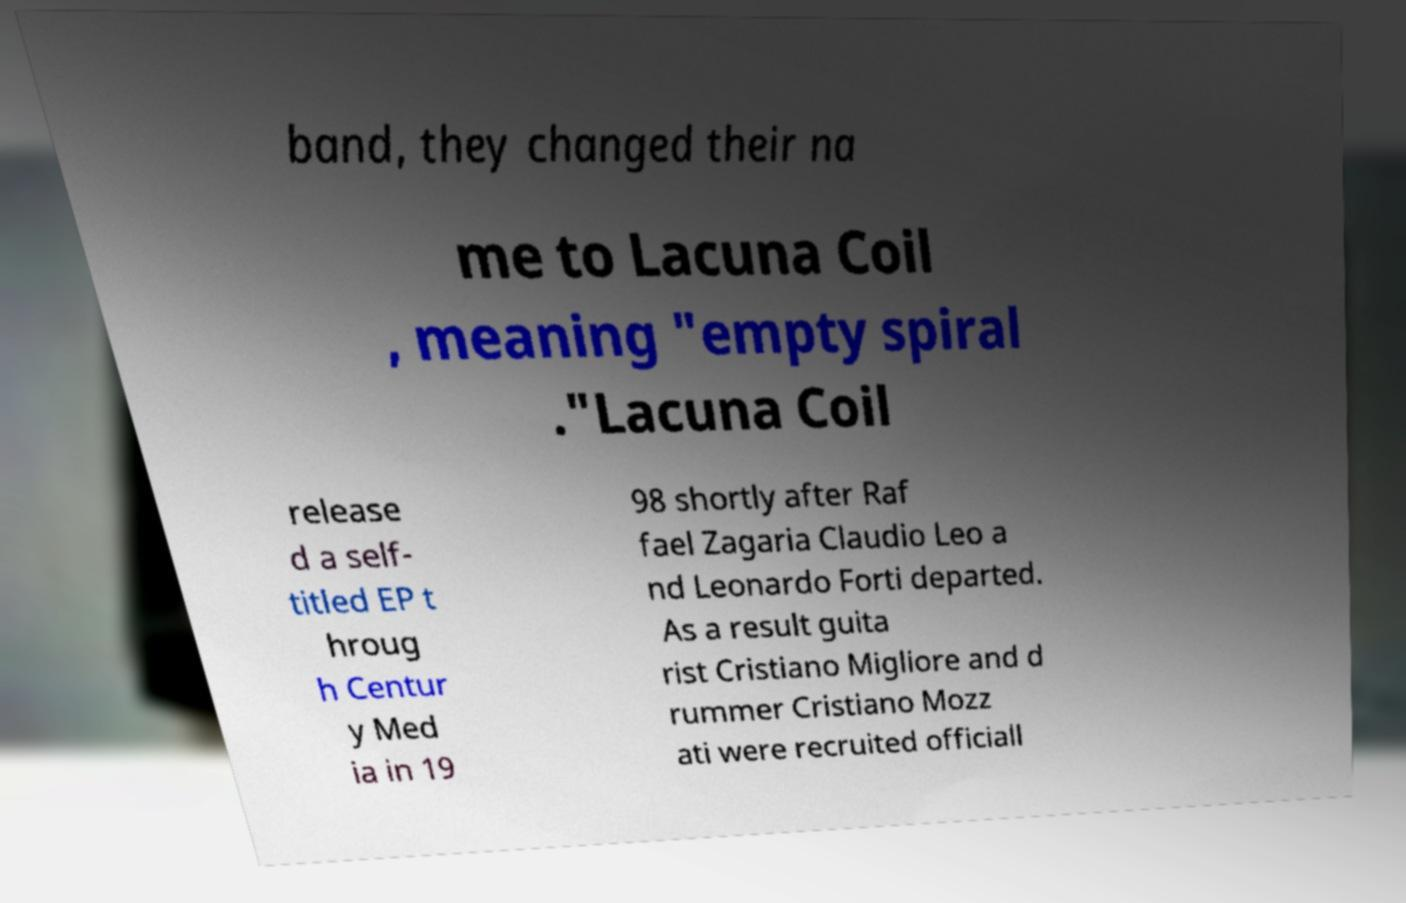There's text embedded in this image that I need extracted. Can you transcribe it verbatim? band, they changed their na me to Lacuna Coil , meaning "empty spiral ."Lacuna Coil release d a self- titled EP t hroug h Centur y Med ia in 19 98 shortly after Raf fael Zagaria Claudio Leo a nd Leonardo Forti departed. As a result guita rist Cristiano Migliore and d rummer Cristiano Mozz ati were recruited officiall 